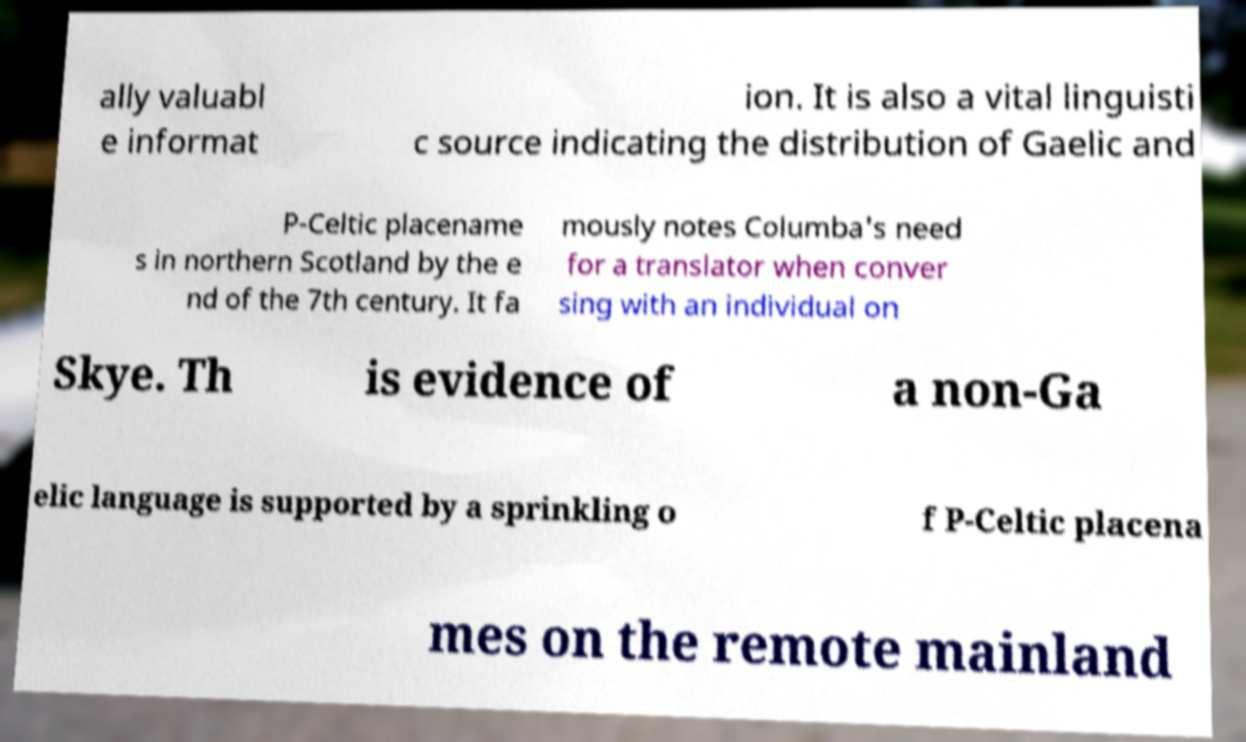Could you extract and type out the text from this image? ally valuabl e informat ion. It is also a vital linguisti c source indicating the distribution of Gaelic and P-Celtic placename s in northern Scotland by the e nd of the 7th century. It fa mously notes Columba's need for a translator when conver sing with an individual on Skye. Th is evidence of a non-Ga elic language is supported by a sprinkling o f P-Celtic placena mes on the remote mainland 